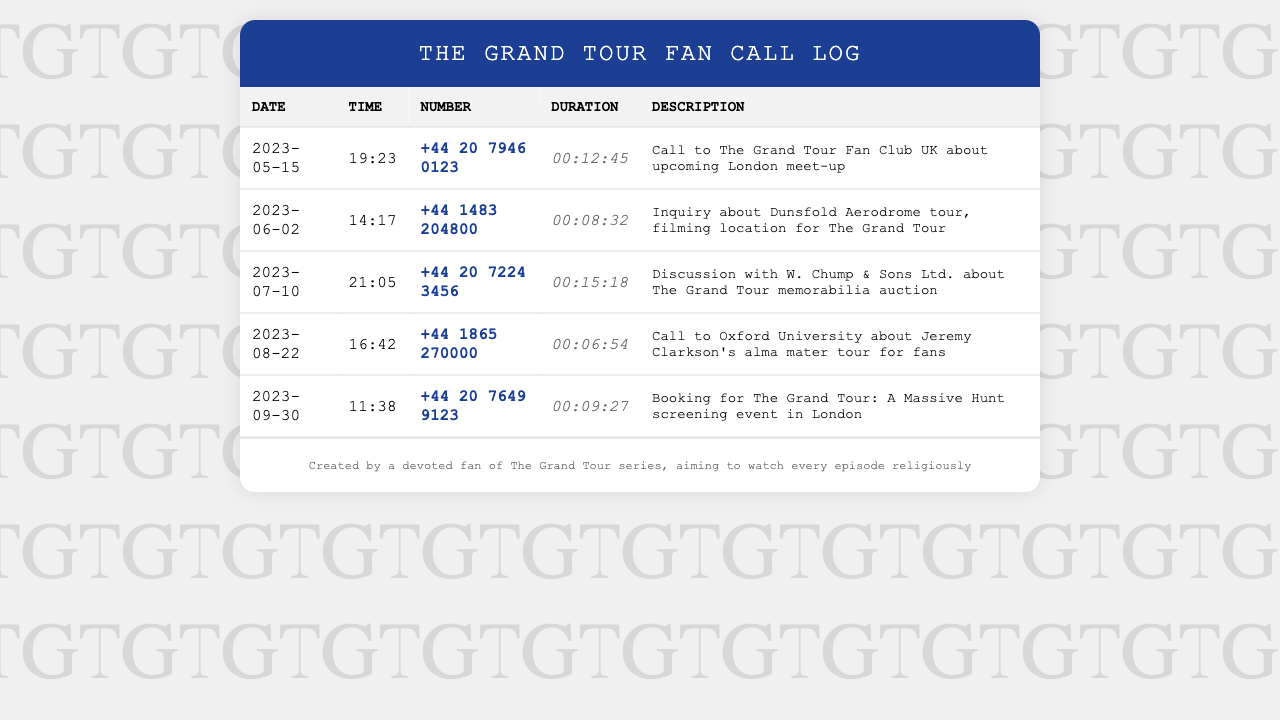What is the date of the call regarding the Dunsfold Aerodrome tour? The specific date for the call about the Dunsfold Aerodrome tour is noted in the document as June 2, 2023.
Answer: June 2, 2023 How long was the call to The Grand Tour Fan Club UK? The duration of the call to The Grand Tour Fan Club UK is stated in the document as 00:12:45.
Answer: 00:12:45 What was discussed during the July 10 call? The document describes this call as a discussion with W. Chump & Sons Ltd. about The Grand Tour memorabilia auction.
Answer: The Grand Tour memorabilia auction How many calls are listed in the document? The total number of calls documented is counted based on the rows in the table, which includes five entries.
Answer: 5 Which number was called for booking the screening event? The document specifies the number called for booking the screening event as +44 20 7649 9123.
Answer: +44 20 7649 9123 What event is mentioned in the August 22 call? The call to Oxford University on August 22 is about Jeremy Clarkson's alma mater tour for fans.
Answer: Jeremy Clarkson's alma mater tour What was the time of the call to Oxford University? The document states the time of the call to Oxford University was at 16:42.
Answer: 16:42 What was the purpose of the first call in the log? The document indicates the purpose of the first call was to discuss an upcoming London meet-up for The Grand Tour fan club.
Answer: Upcoming London meet-up 